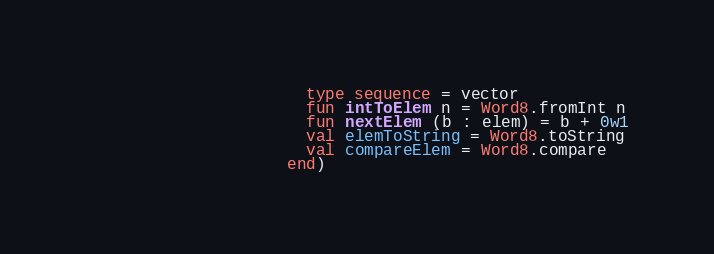<code> <loc_0><loc_0><loc_500><loc_500><_SML_>                       type sequence = vector
                       fun intToElem n = Word8.fromInt n
                       fun nextElem (b : elem) = b + 0w1
                       val elemToString = Word8.toString
                       val compareElem = Word8.compare
                     end)
</code> 